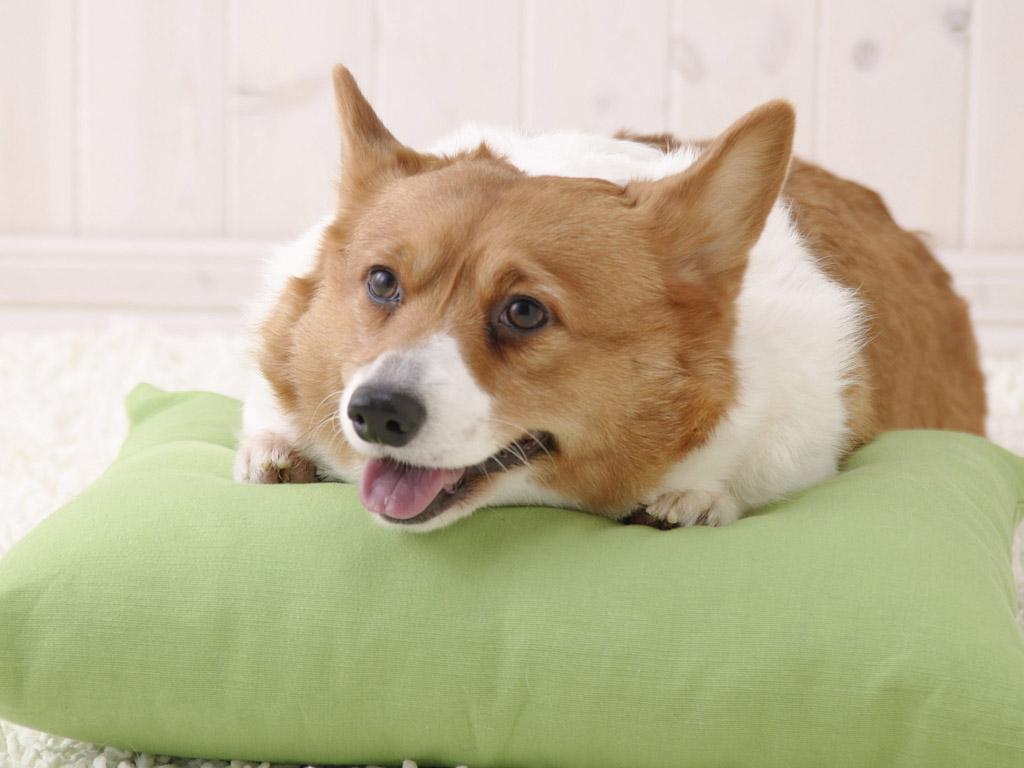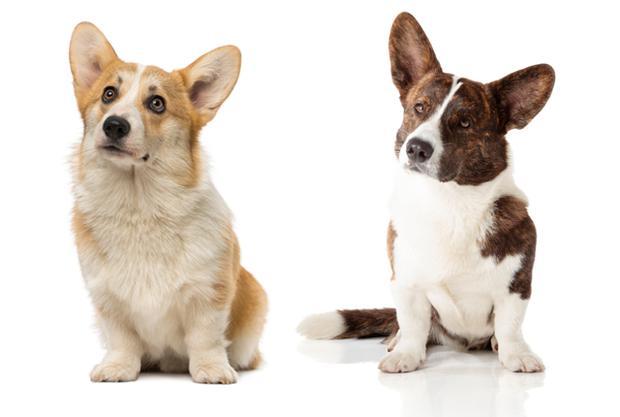The first image is the image on the left, the second image is the image on the right. Analyze the images presented: Is the assertion "One image has exactly one dog." valid? Answer yes or no. Yes. The first image is the image on the left, the second image is the image on the right. For the images displayed, is the sentence "There are three dogs" factually correct? Answer yes or no. Yes. 